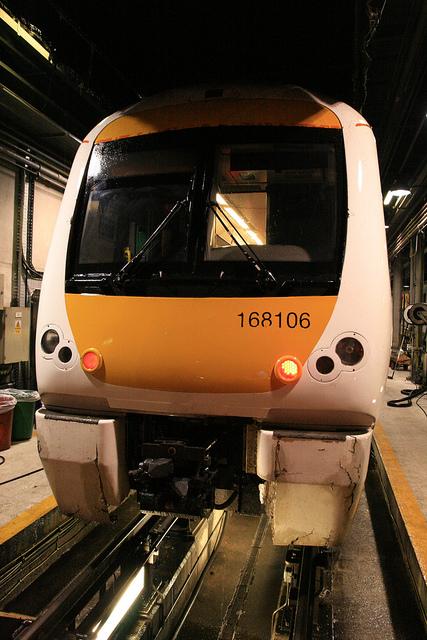What color is the front of the train?
Answer briefly. Orange. Is this at a rider platform?
Concise answer only. Yes. What type of transportation is this?
Concise answer only. Train. 